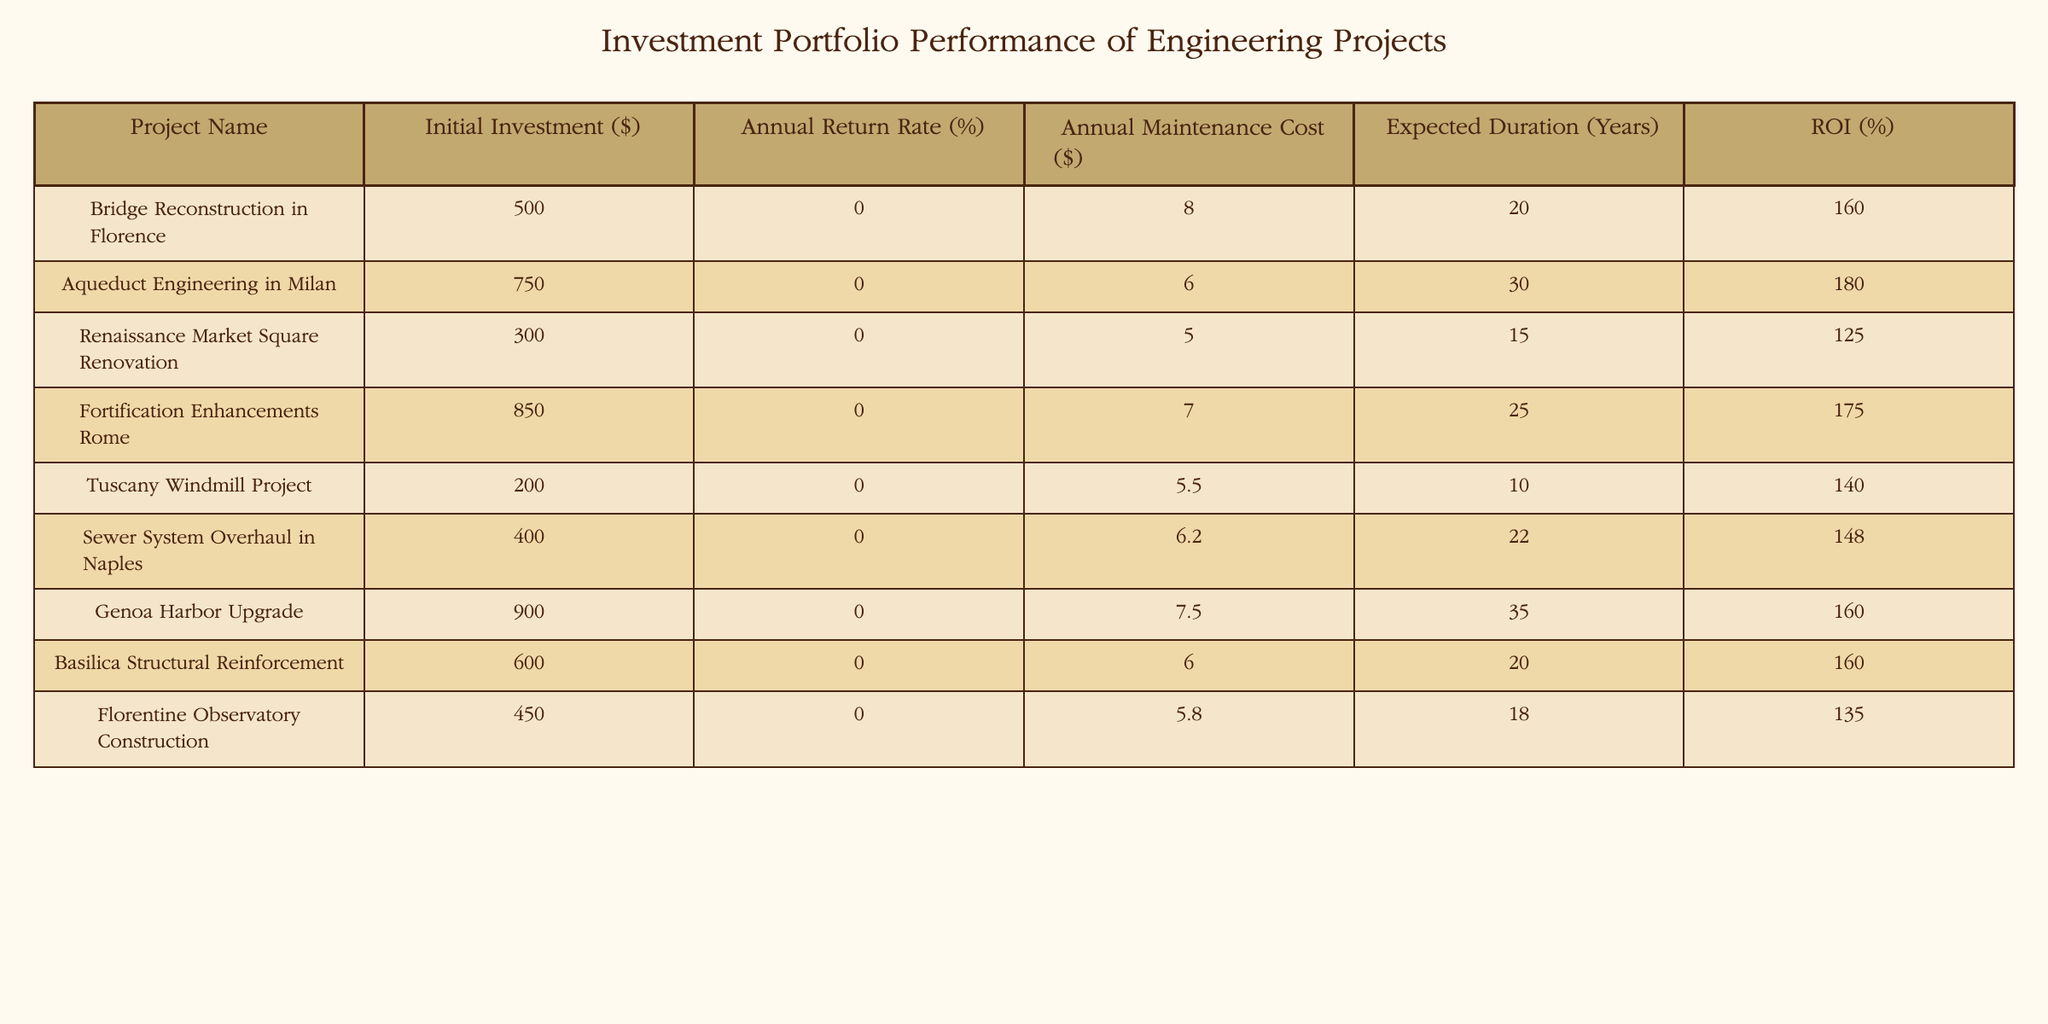What is the initial investment for the Bridge Reconstruction in Florence? The table shows that the initial investment for the Bridge Reconstruction in Florence is listed directly in the "Initial Investment ($)" column. It reads 500,000.
Answer: 500,000 What is the annual return rate for the Aqueduct Engineering in Milan? The annual return rate is found in the "Annual Return Rate (%)" column corresponding to the Aqueduct Engineering project, which is stated as 6.
Answer: 6 Which project has the highest expected duration? To find the project with the highest expected duration, I look at the "Expected Duration (Years)" column and identify the value 35, which corresponds to the Genoa Harbor Upgrade project.
Answer: Genoa Harbor Upgrade What is the average annual maintenance cost of all the projects? First, I sum the values in the "Annual Maintenance Cost ($)" column: 20 + 30 + 15 + 25 + 10 + 22 + 35 + 20 + 18 = 195. There are 9 projects, so I divide the total by 9, resulting in 195/9 ≈ 21.67.
Answer: 21.67 Is the ROI for the Tuscany Windmill Project higher than that of the Bridge Reconstruction in Florence? The ROI for the Tuscany Windmill Project is 140% and for the Bridge Reconstruction it is 160%. Since 140 is less than 160, the statement is false.
Answer: No Which project has the lowest annual return rate? By looking through the "Annual Return Rate (%)" column, I see the lowest value is 5%, which corresponds to the Renaissance Market Square Renovation project.
Answer: Renaissance Market Square Renovation What is the difference in ROI between the Fortification Enhancements Rome and the Sewer System Overhaul in Naples? The ROI for Fortification Enhancements Rome is 175%, and for Sewer System Overhaul it is 148%. To find the difference, I calculate 175 - 148 = 27.
Answer: 27 Are there any projects with an initial investment under 300,000? An analysis of the "Initial Investment ($)" column shows that the lowest value is 200,000 for the Tuscany Windmill Project. Therefore, there is at least one project under 300,000, making the statement true.
Answer: Yes What is the total ROI for all projects combined? I will sum the ROI values: 160 + 180 + 125 + 175 + 140 + 148 + 160 + 160 + 135 = 1283. Thus, the total ROI for all projects is 1283%.
Answer: 1283 